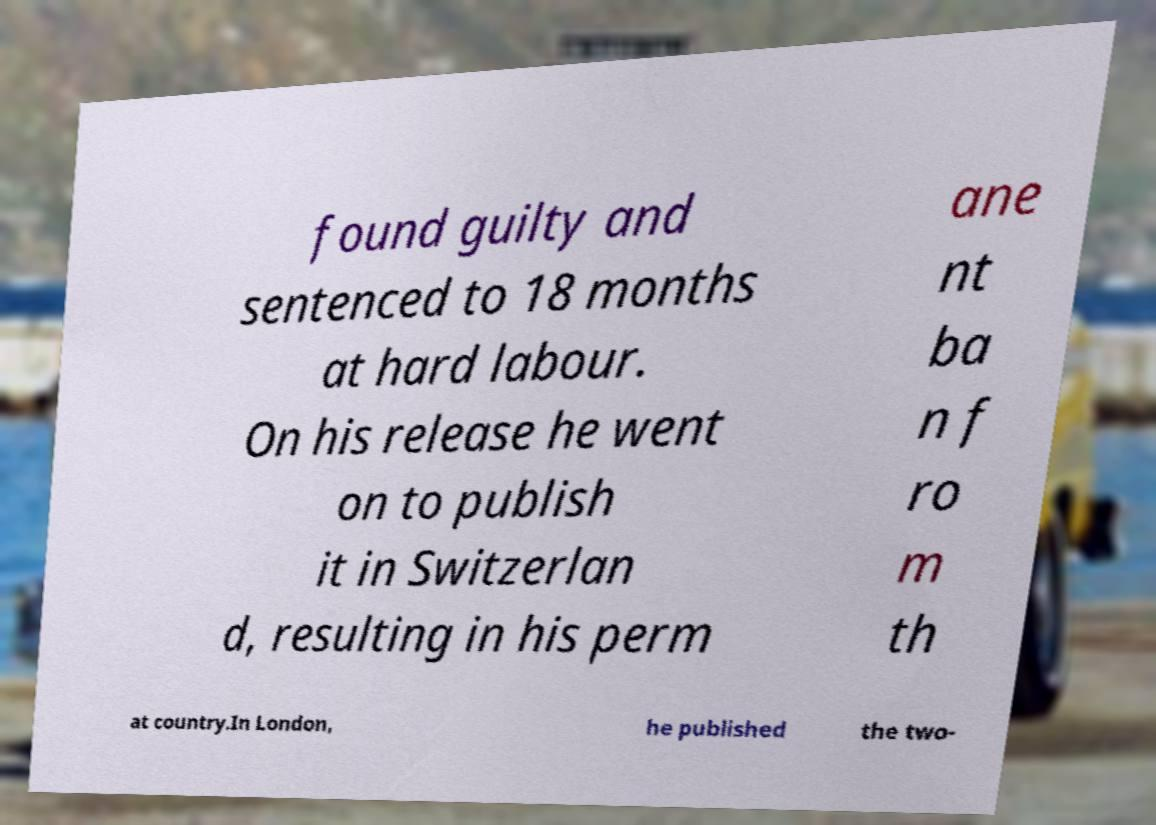Can you accurately transcribe the text from the provided image for me? found guilty and sentenced to 18 months at hard labour. On his release he went on to publish it in Switzerlan d, resulting in his perm ane nt ba n f ro m th at country.In London, he published the two- 